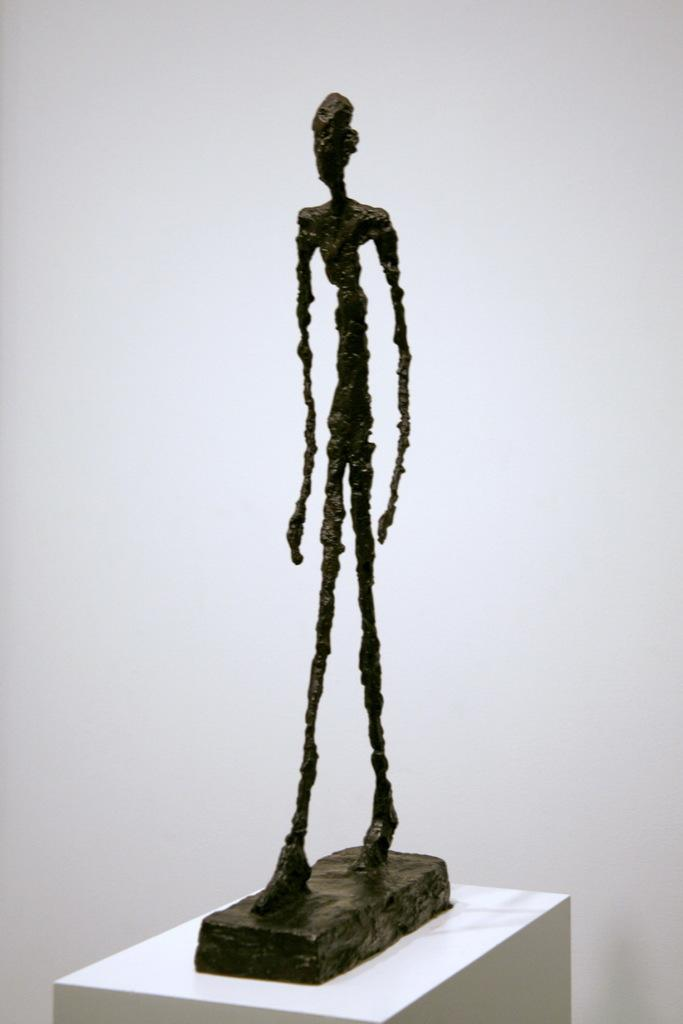What is the color of the object in the image? The object in the image is black. Where is the black object placed? The black object is on a white box. What is the color of the background in the image? The background of the image is white in color. How many cars can be seen on the tray in the image? There is no tray or cars present in the image. What type of rifle is visible in the image? There is no rifle present in the image. 